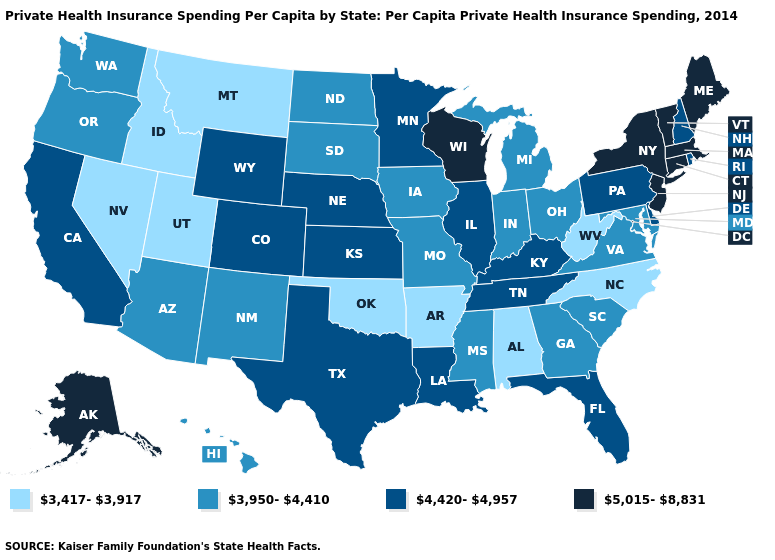Among the states that border Indiana , does Ohio have the highest value?
Concise answer only. No. Does Alaska have the lowest value in the West?
Concise answer only. No. What is the value of Florida?
Quick response, please. 4,420-4,957. What is the value of Oklahoma?
Keep it brief. 3,417-3,917. Which states hav the highest value in the South?
Give a very brief answer. Delaware, Florida, Kentucky, Louisiana, Tennessee, Texas. What is the highest value in the USA?
Short answer required. 5,015-8,831. Which states have the lowest value in the MidWest?
Answer briefly. Indiana, Iowa, Michigan, Missouri, North Dakota, Ohio, South Dakota. Does Kansas have a higher value than West Virginia?
Quick response, please. Yes. Name the states that have a value in the range 5,015-8,831?
Quick response, please. Alaska, Connecticut, Maine, Massachusetts, New Jersey, New York, Vermont, Wisconsin. Name the states that have a value in the range 4,420-4,957?
Be succinct. California, Colorado, Delaware, Florida, Illinois, Kansas, Kentucky, Louisiana, Minnesota, Nebraska, New Hampshire, Pennsylvania, Rhode Island, Tennessee, Texas, Wyoming. What is the highest value in the USA?
Concise answer only. 5,015-8,831. What is the value of North Dakota?
Give a very brief answer. 3,950-4,410. Does Utah have the lowest value in the West?
Write a very short answer. Yes. Name the states that have a value in the range 4,420-4,957?
Short answer required. California, Colorado, Delaware, Florida, Illinois, Kansas, Kentucky, Louisiana, Minnesota, Nebraska, New Hampshire, Pennsylvania, Rhode Island, Tennessee, Texas, Wyoming. What is the lowest value in states that border Texas?
Write a very short answer. 3,417-3,917. 